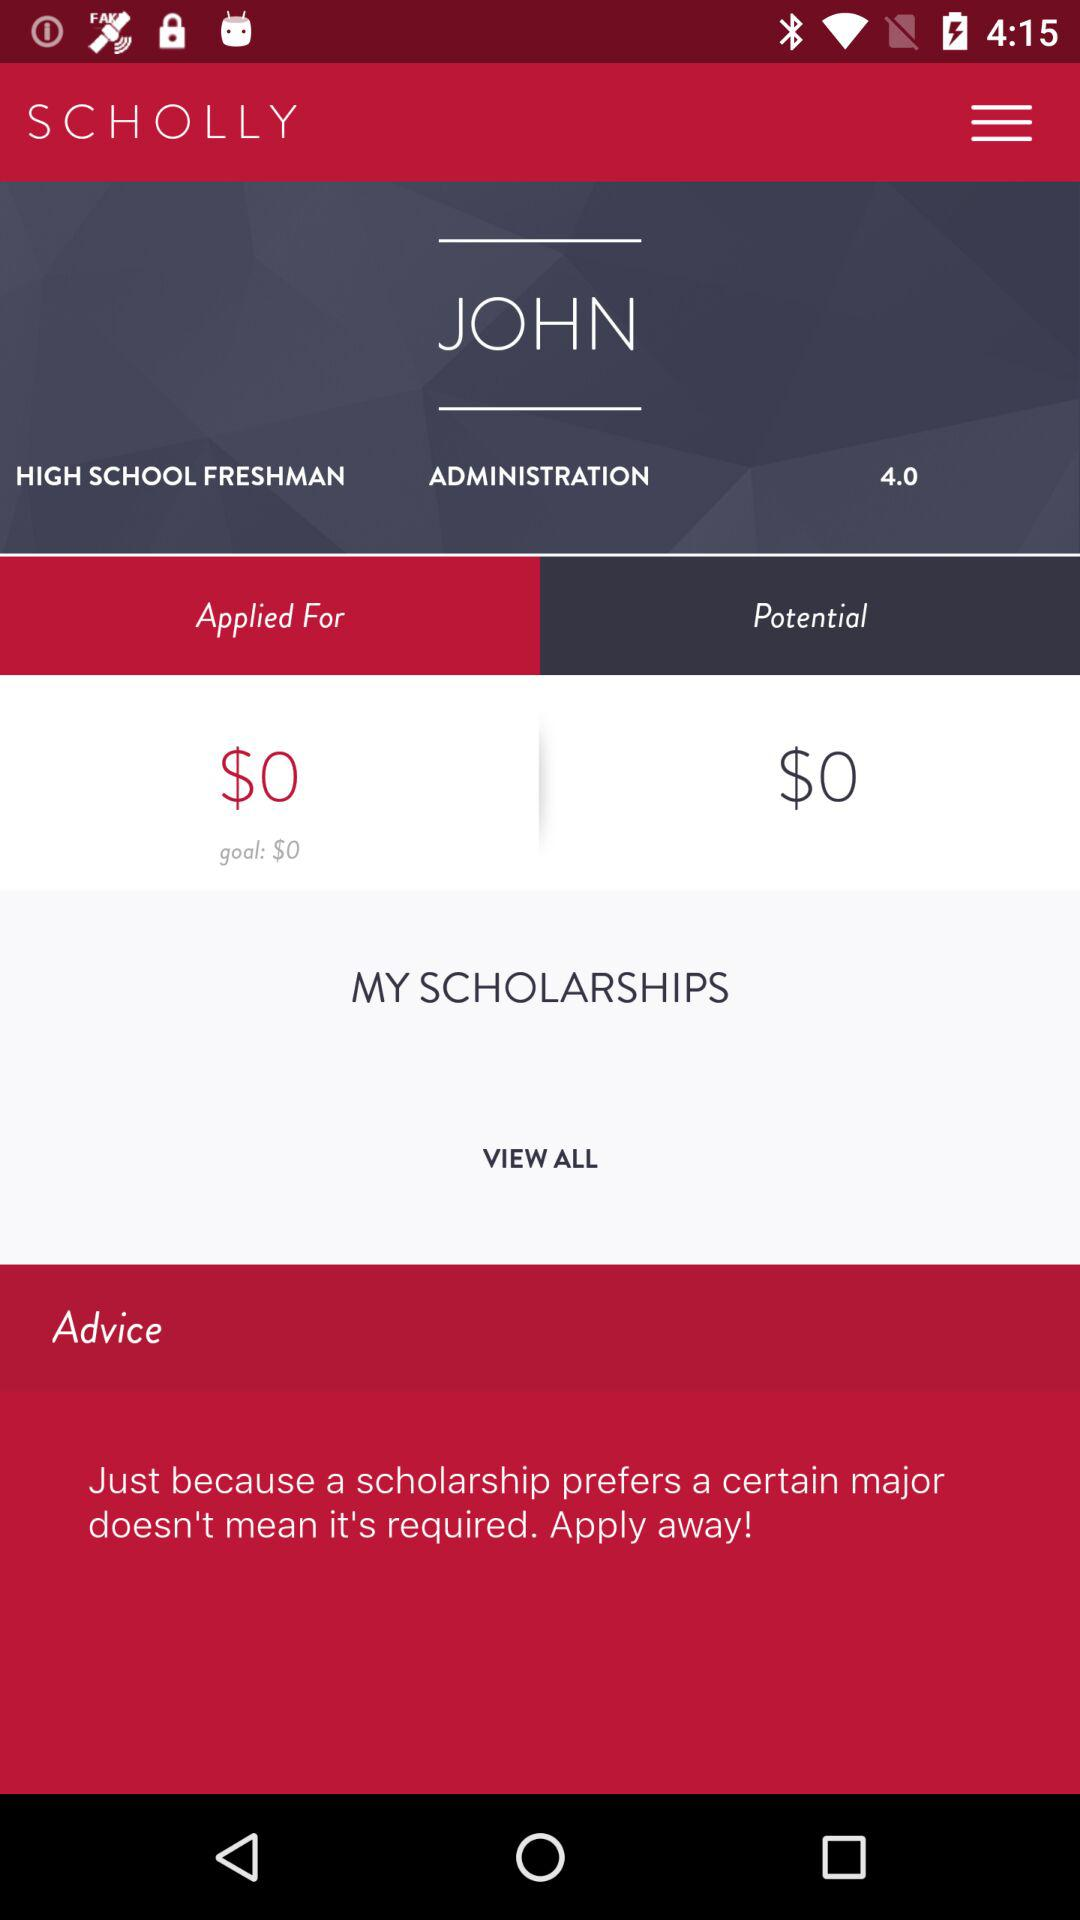What is the rating there? The rating is 4.0. 